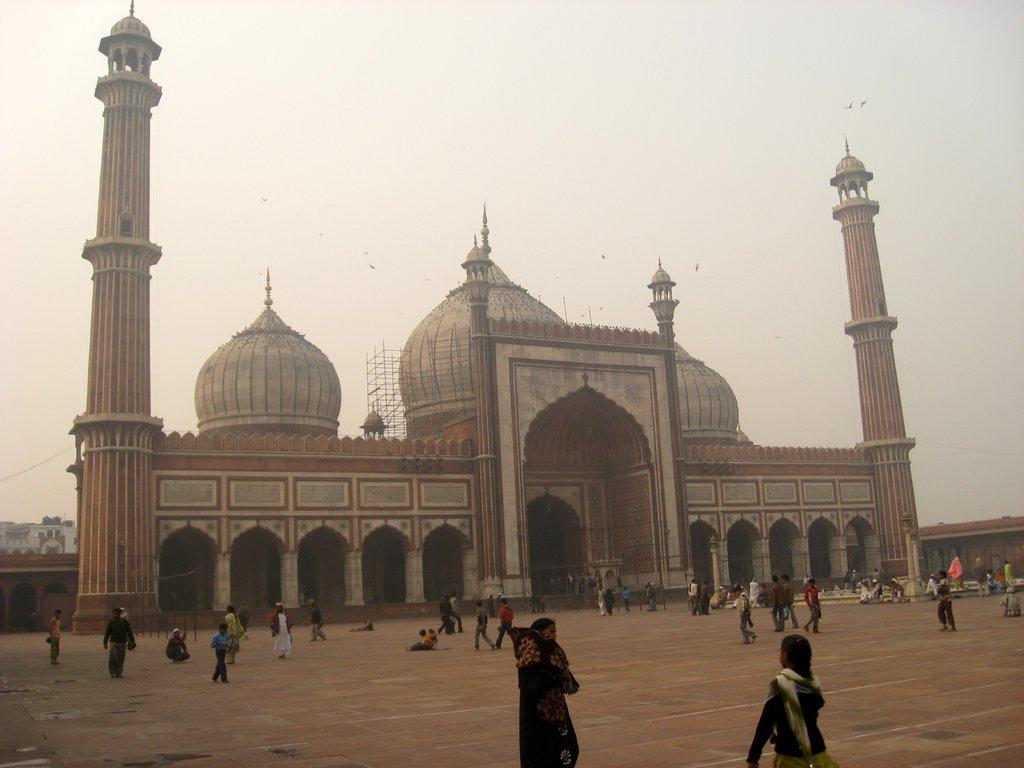Who or what can be seen at the bottom of the image? There are people present at the bottom of the image. What structure is located in the middle of the image? There is a building in the middle of the image. What part of the natural environment is visible in the image? The sky is visible in the background of the image. Can you tell me how many fans are visible in the image? There are no fans present in the image. What type of airplane can be seen flying in the background of the image? There is no airplane visible in the image; only the people, building, and sky are present. 